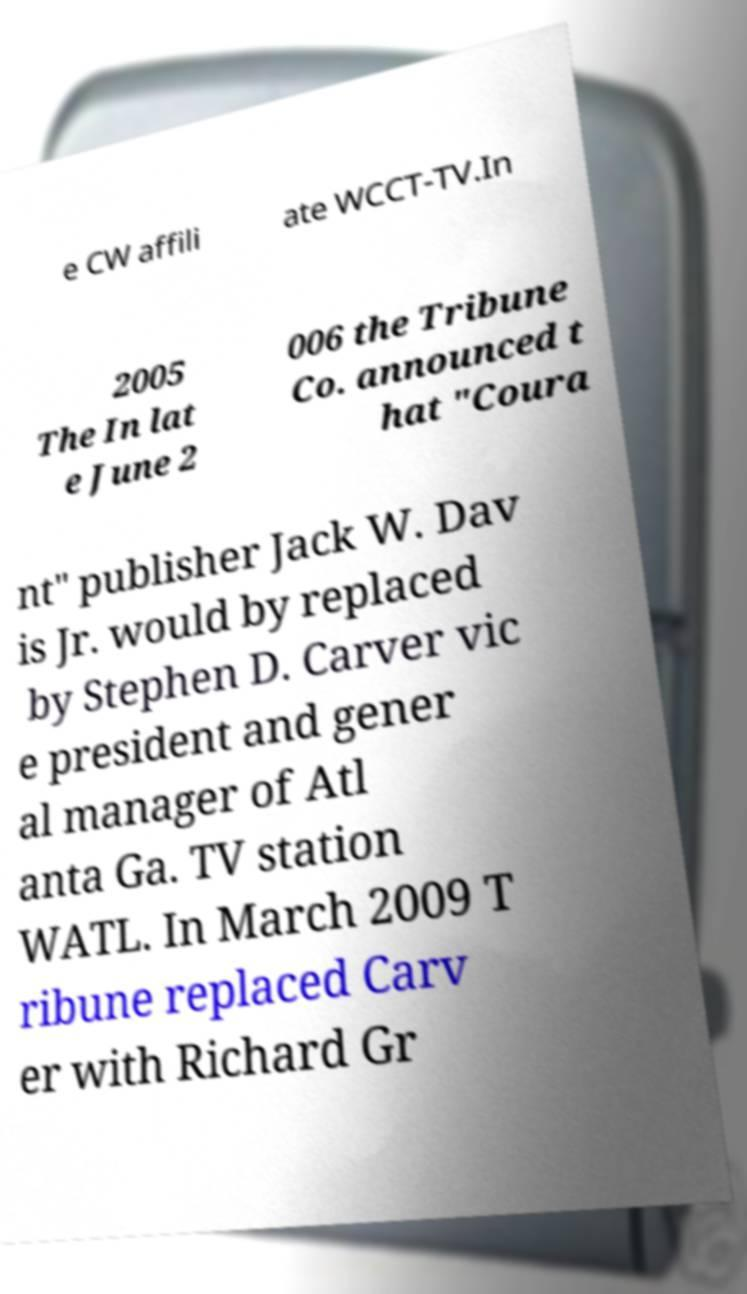Can you accurately transcribe the text from the provided image for me? e CW affili ate WCCT-TV.In 2005 The In lat e June 2 006 the Tribune Co. announced t hat "Coura nt" publisher Jack W. Dav is Jr. would by replaced by Stephen D. Carver vic e president and gener al manager of Atl anta Ga. TV station WATL. In March 2009 T ribune replaced Carv er with Richard Gr 